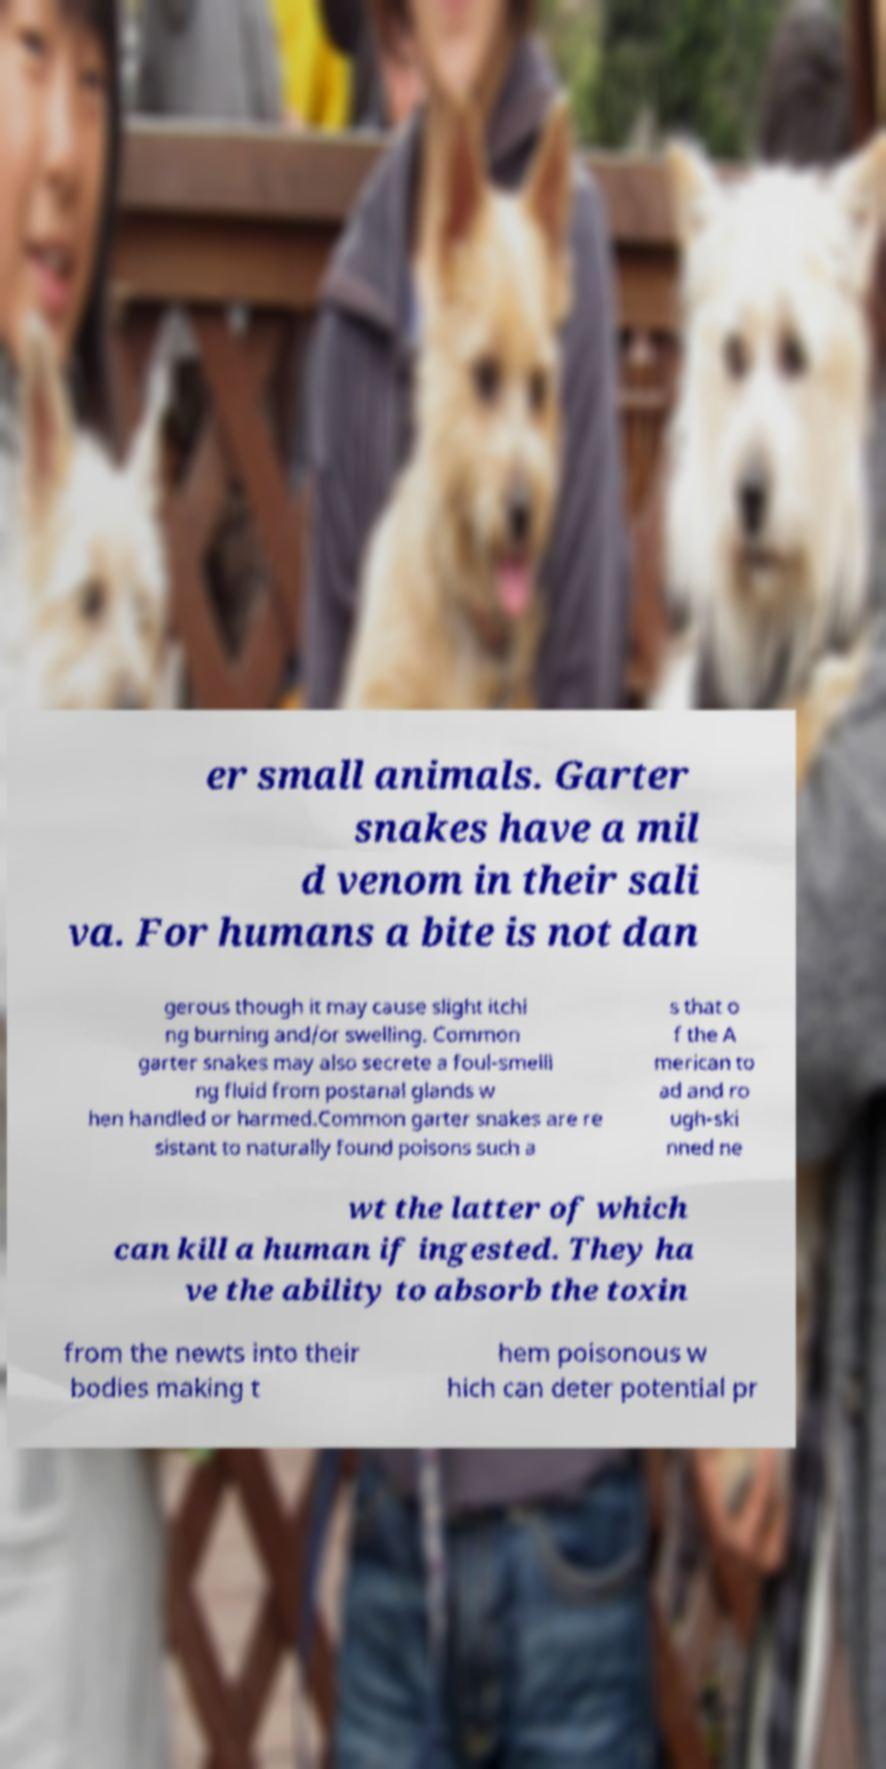For documentation purposes, I need the text within this image transcribed. Could you provide that? er small animals. Garter snakes have a mil d venom in their sali va. For humans a bite is not dan gerous though it may cause slight itchi ng burning and/or swelling. Common garter snakes may also secrete a foul-smelli ng fluid from postanal glands w hen handled or harmed.Common garter snakes are re sistant to naturally found poisons such a s that o f the A merican to ad and ro ugh-ski nned ne wt the latter of which can kill a human if ingested. They ha ve the ability to absorb the toxin from the newts into their bodies making t hem poisonous w hich can deter potential pr 